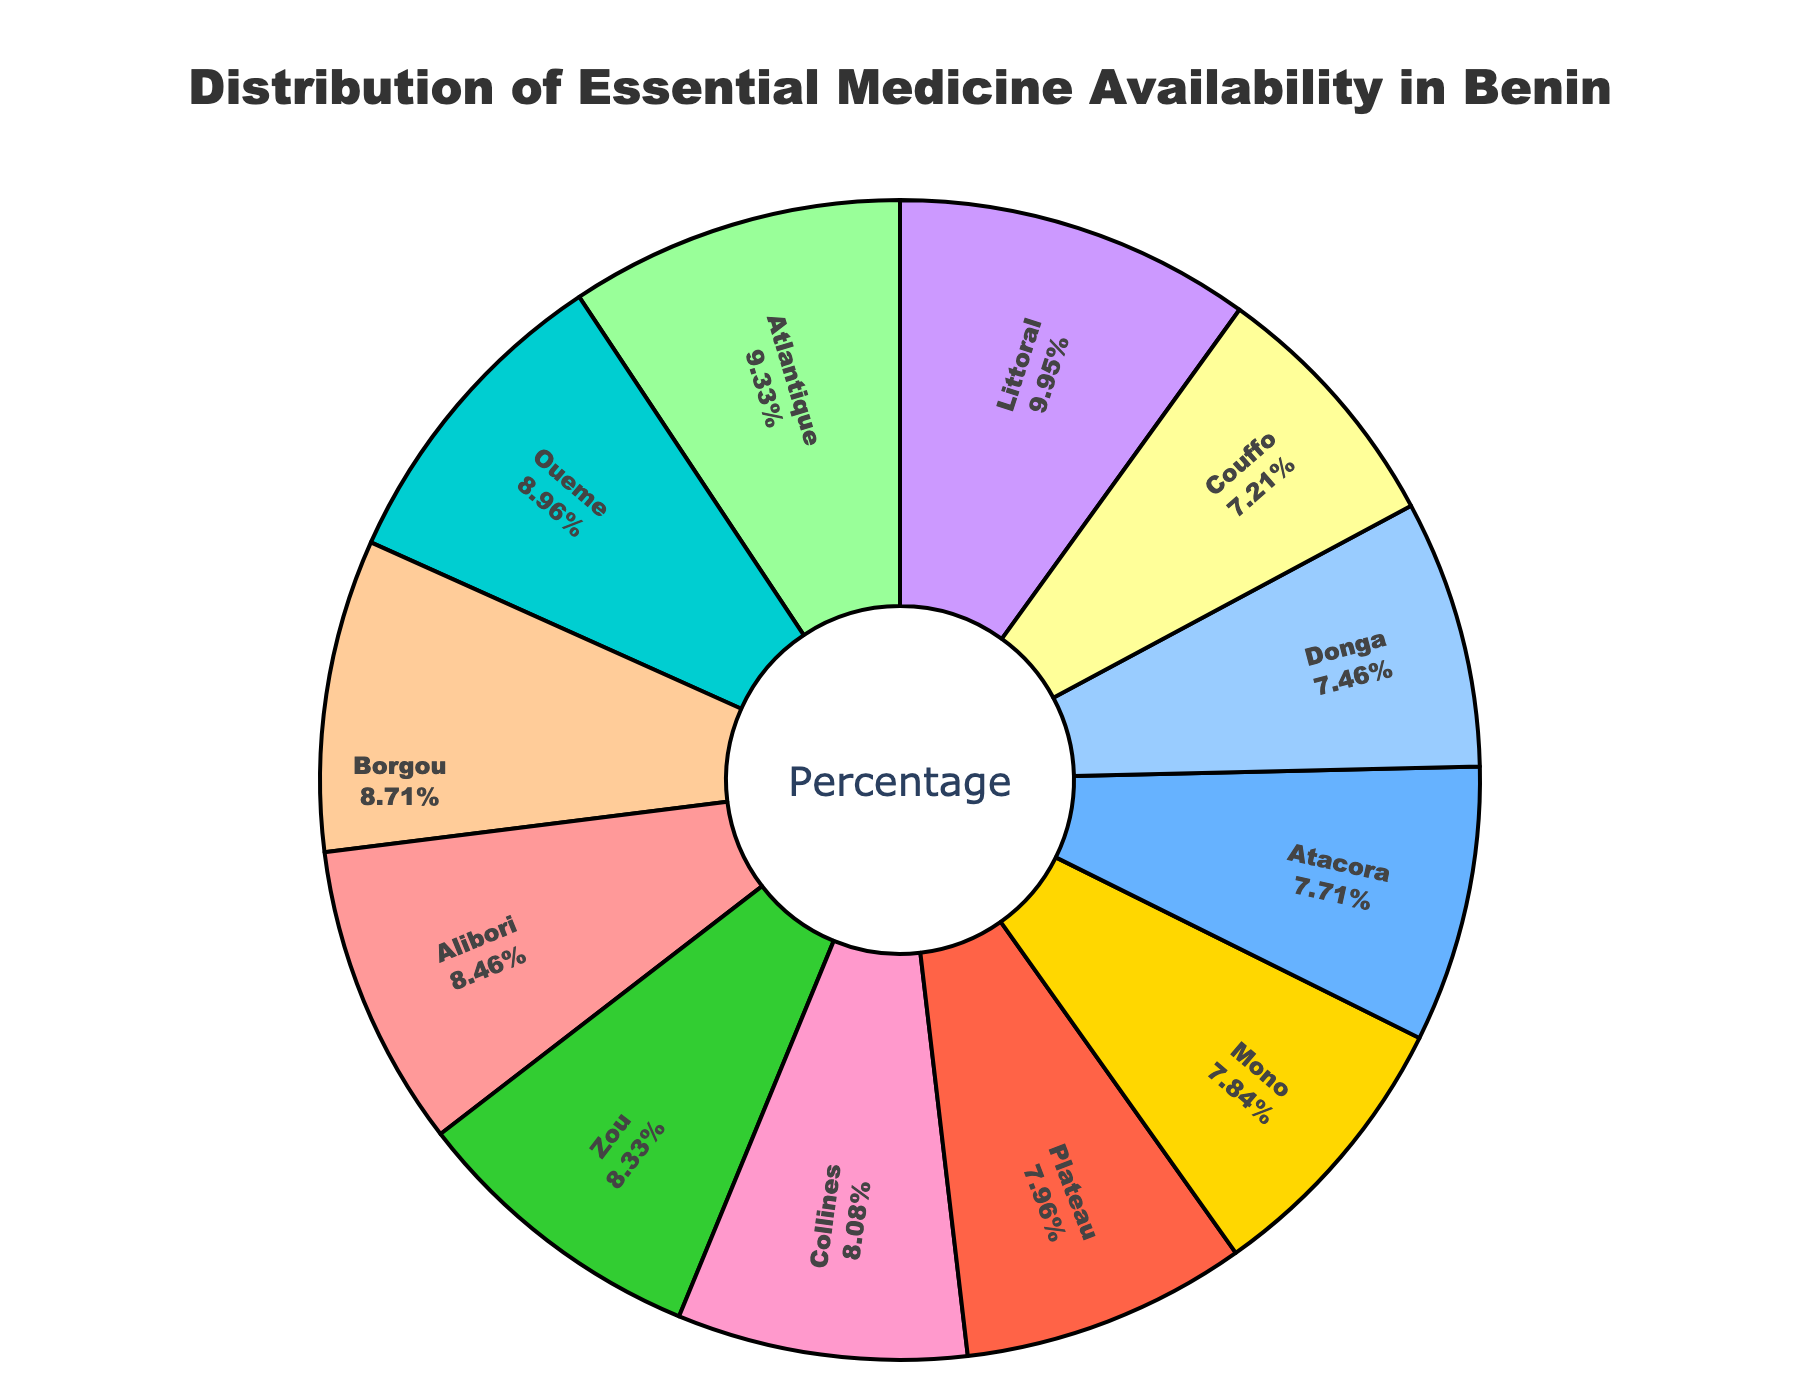What is the total percentage of essential medicine availability in Alibori and Mono combined? Alibori has an availability percentage of 68% and Mono has 63%. Adding these together: 68% + 63% = 131%
Answer: 131% Which region has the highest essential medicine availability percentage? The region with the highest availability percentage is the region that has the largest segment in the pie chart and shows the highest value. In this case, it's Littoral with 80%.
Answer: Littoral Are there more regions with an availability percentage greater than or equal to 70% or less than 70%? Count the regions with percentages >= 70%: Atlantique (75%), Borgou (70%), Oueme (72%), Littoral (80%) - 4 regions. Count the regions with percentages < 70%: Alibori (68%), Atacora (62%), Collines (65%), Couffo (58%), Donga (60%), Mono (63%), Plateau (64%), Zou (67%) - 8 regions. There are more regions with availability percentages less than 70%.
Answer: Less than 70% Which regions have an availability percentage between 60% and 70%? Identify regions within the range of 60% to 70%. They are: Alibori (68%), Atacora (62%), Borgou (70%), Collines (65%), Donga (60%), Mono (63%), Plateau (64%), Zou (67%)
Answer: Alibori, Atacora, Borgou, Collines, Donga, Mono, Plateau, Zou 